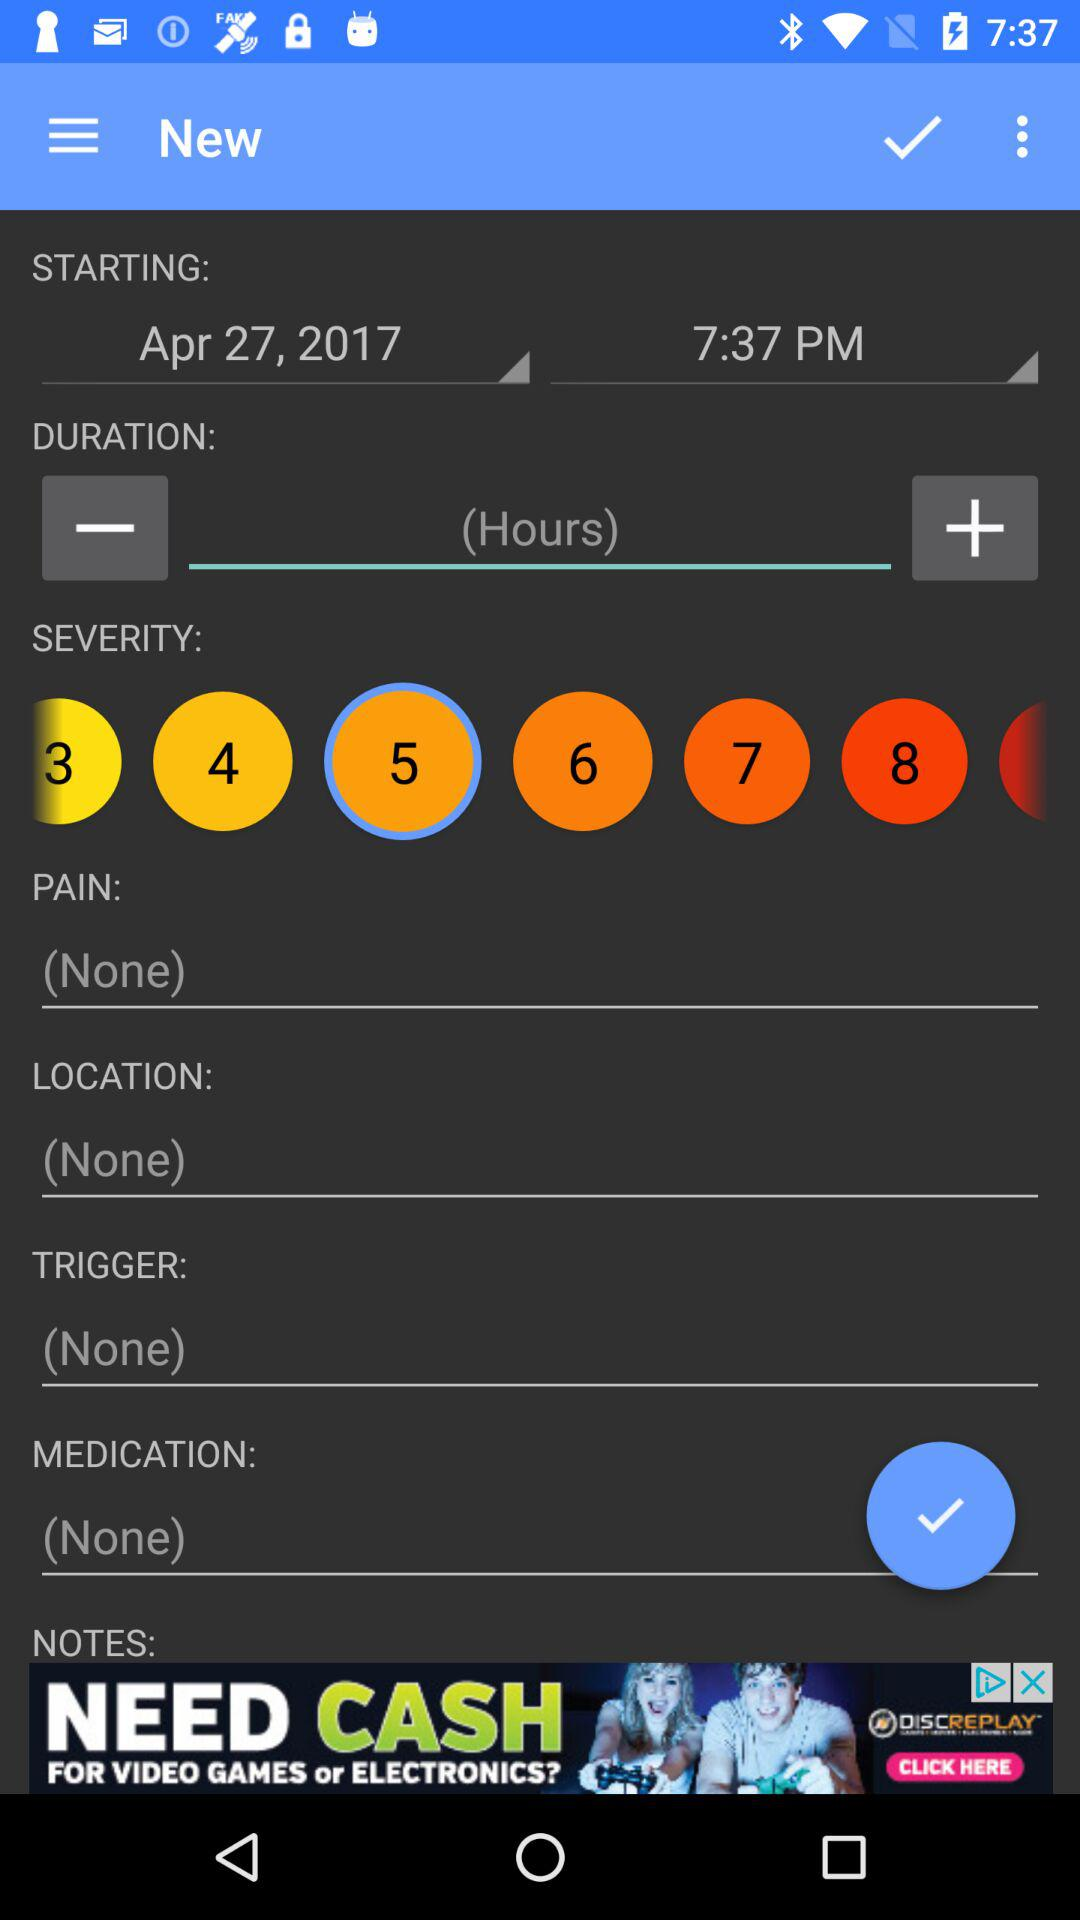What is the starting date of medication? The starting date of medication is April 27, 2017. 